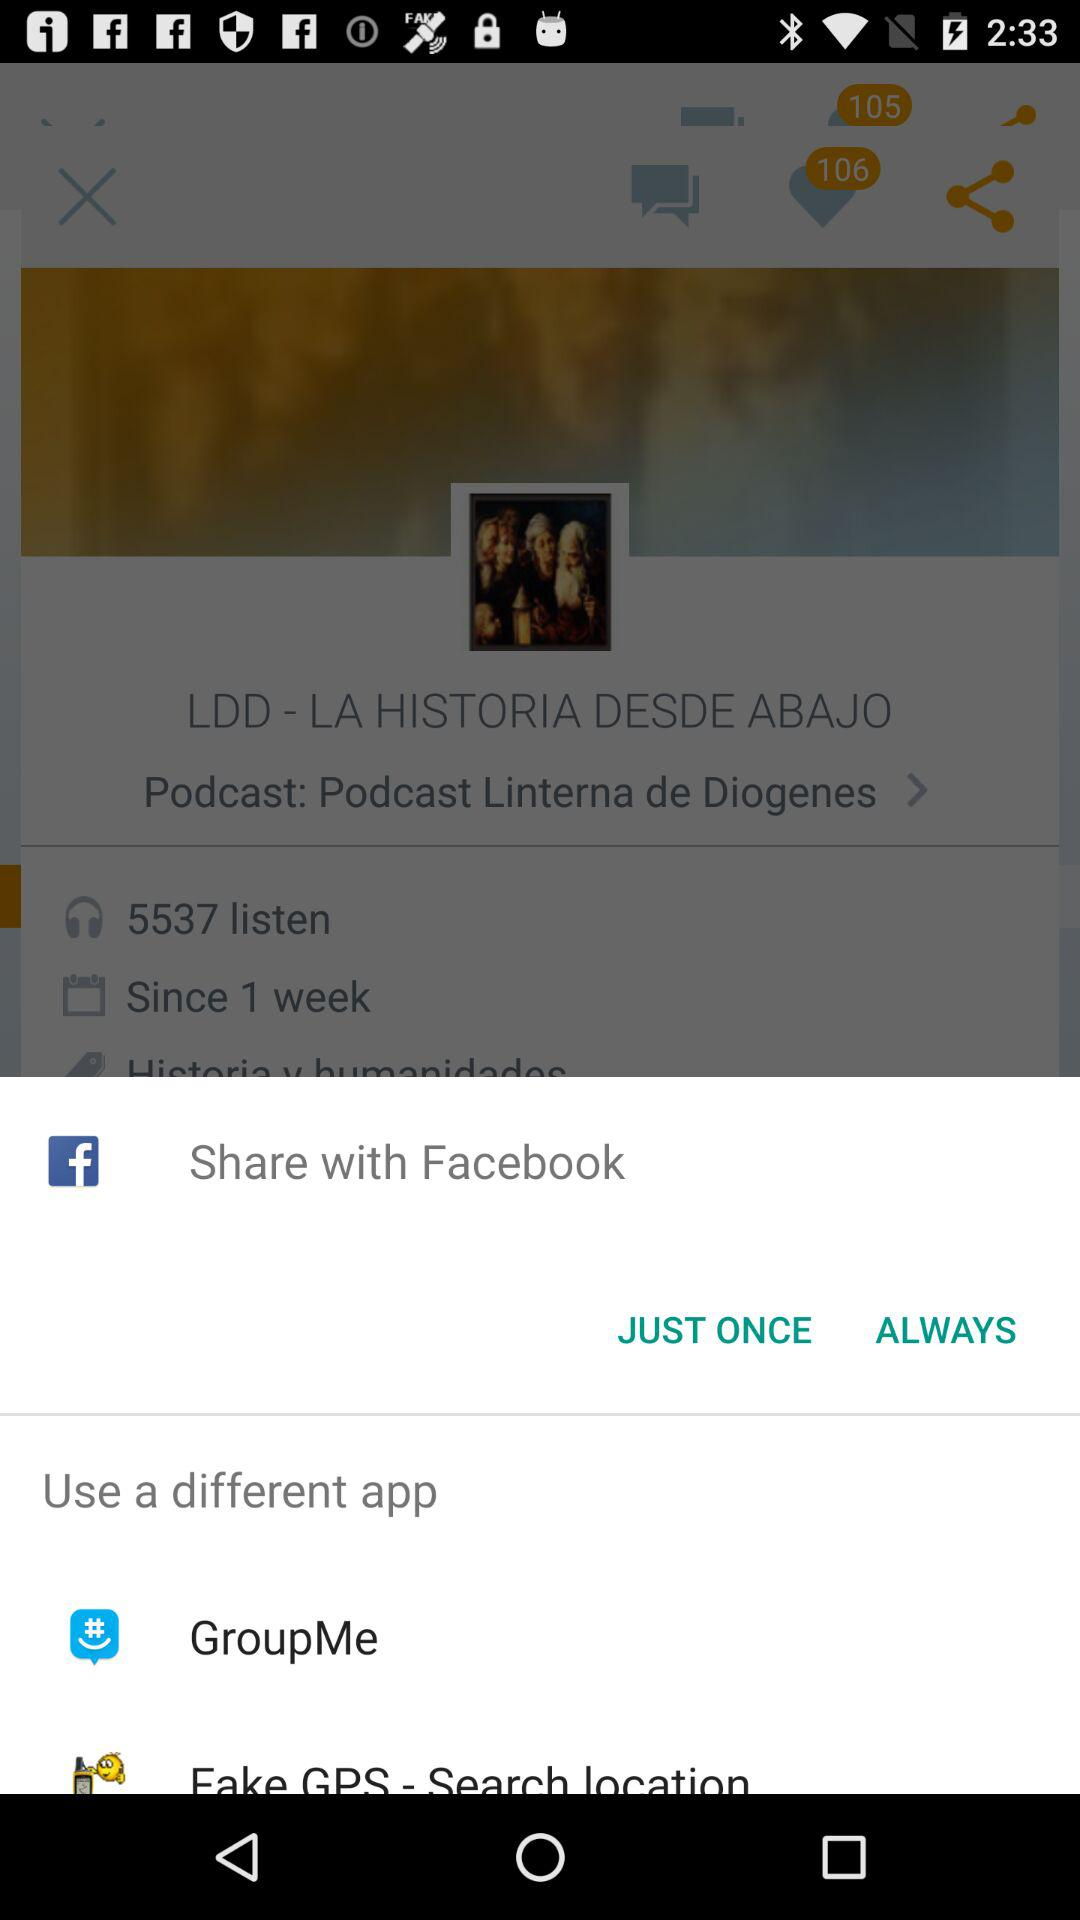When was the podcast uploaded?
When the provided information is insufficient, respond with <no answer>. <no answer> 